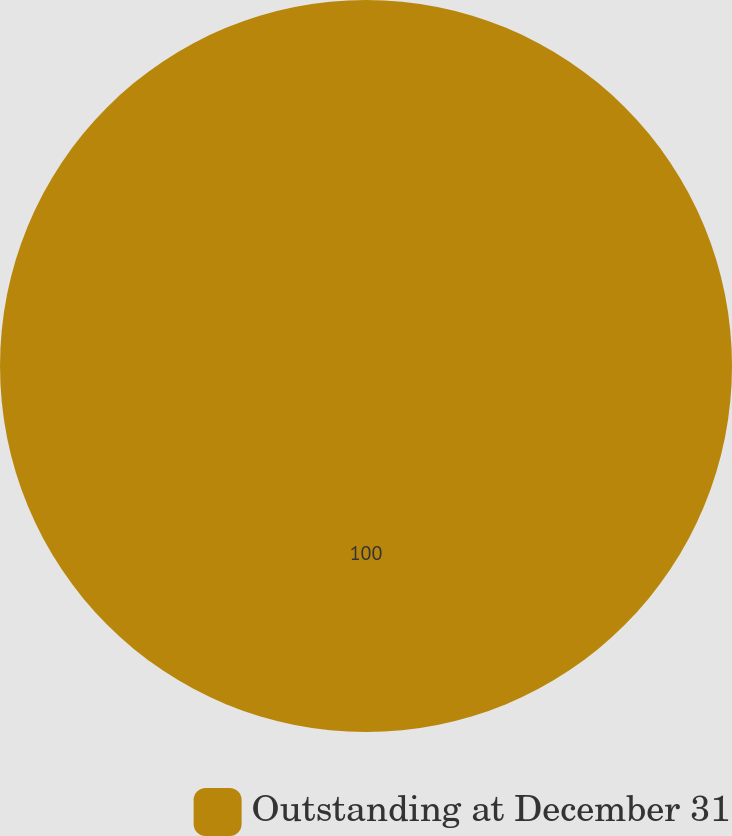Convert chart to OTSL. <chart><loc_0><loc_0><loc_500><loc_500><pie_chart><fcel>Outstanding at December 31<nl><fcel>100.0%<nl></chart> 